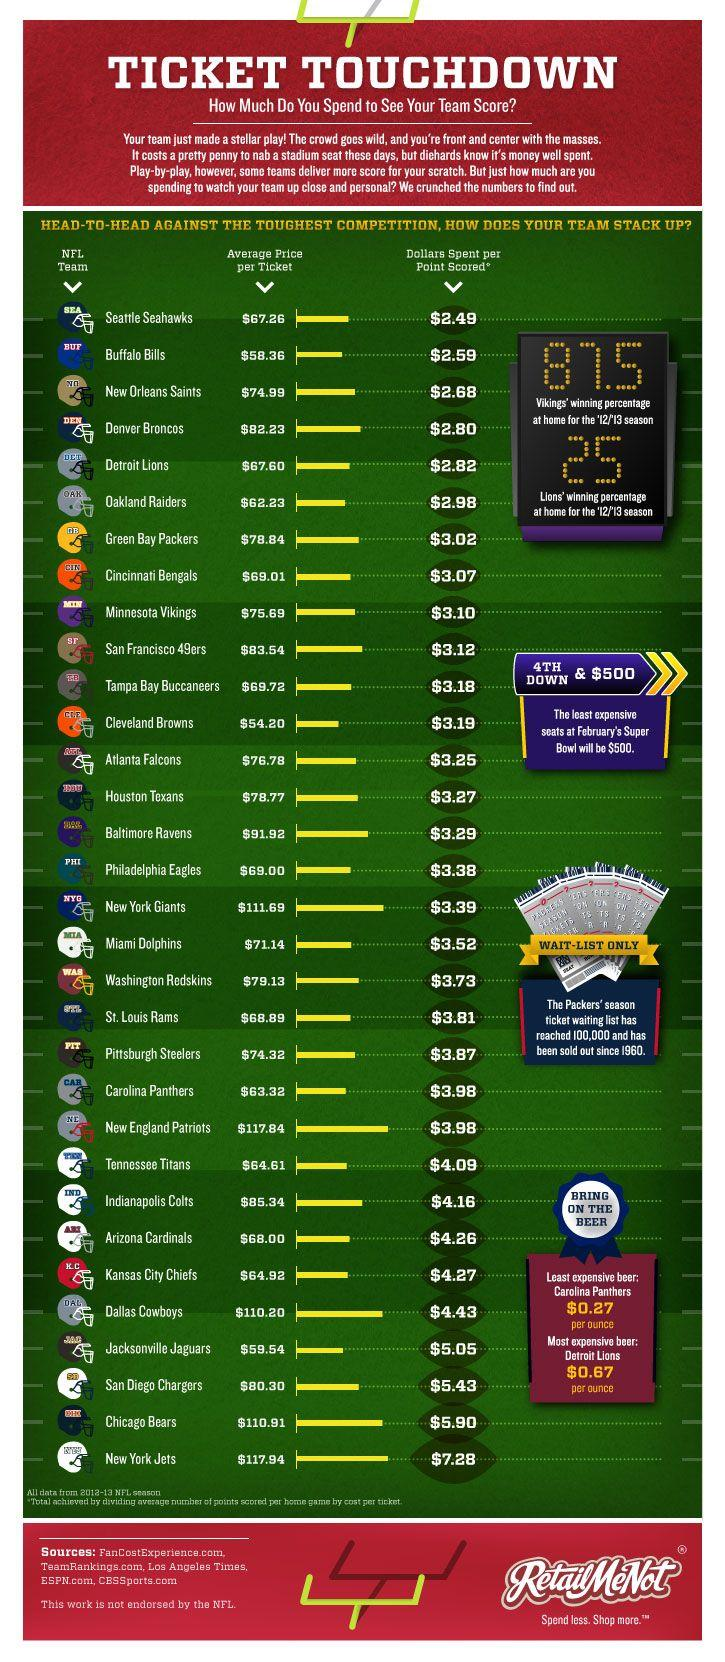Identify some key points in this picture. The least expensive beer can be purchased for $0.27. The most expensive beer costs $0.67. The New England Patriots have the second highest average price per ticket among all teams. The Cleveland Browns have the lowest average price per ticket among all teams. 